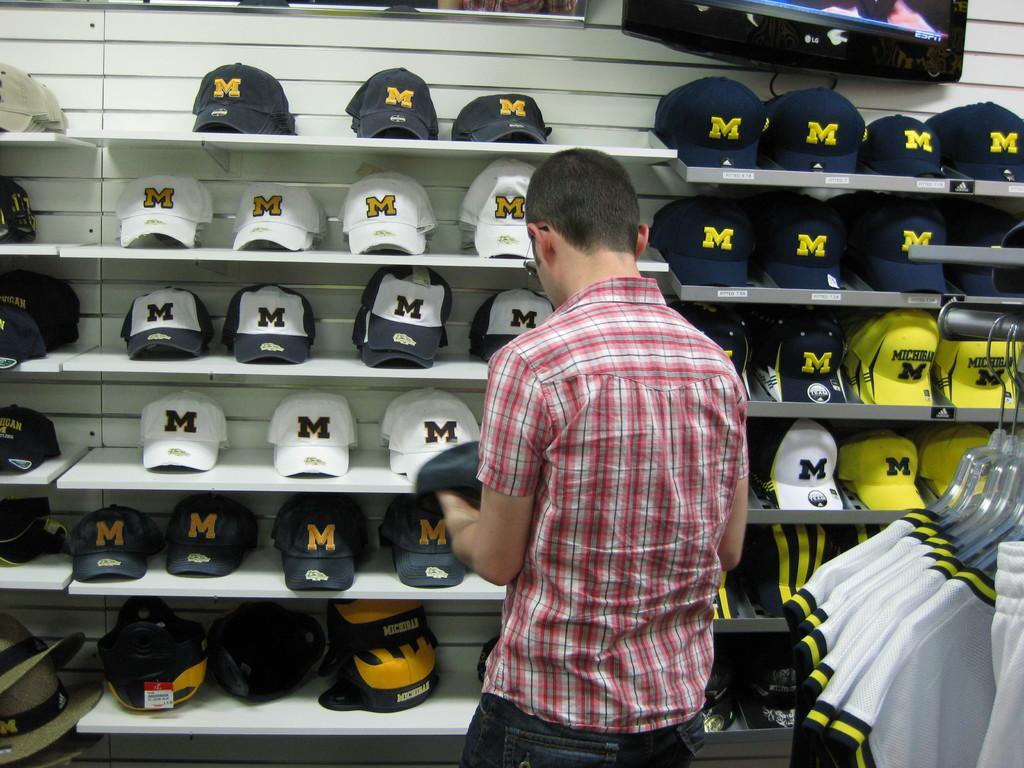Please provide a concise description of this image. In this picture we can see a man standing and beside him we can see clothes are hanging to the hangers and in front of him we can see caps in racks and a television on the wall and some objects. 